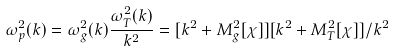Convert formula to latex. <formula><loc_0><loc_0><loc_500><loc_500>\omega _ { p } ^ { 2 } ( k ) = \omega _ { g } ^ { 2 } ( k ) \frac { \omega _ { T } ^ { 2 } ( k ) } { k ^ { 2 } } = [ k ^ { 2 } + M _ { g } ^ { 2 } [ \chi ] ] [ k ^ { 2 } + M _ { T } ^ { 2 } [ \chi ] ] / k ^ { 2 }</formula> 